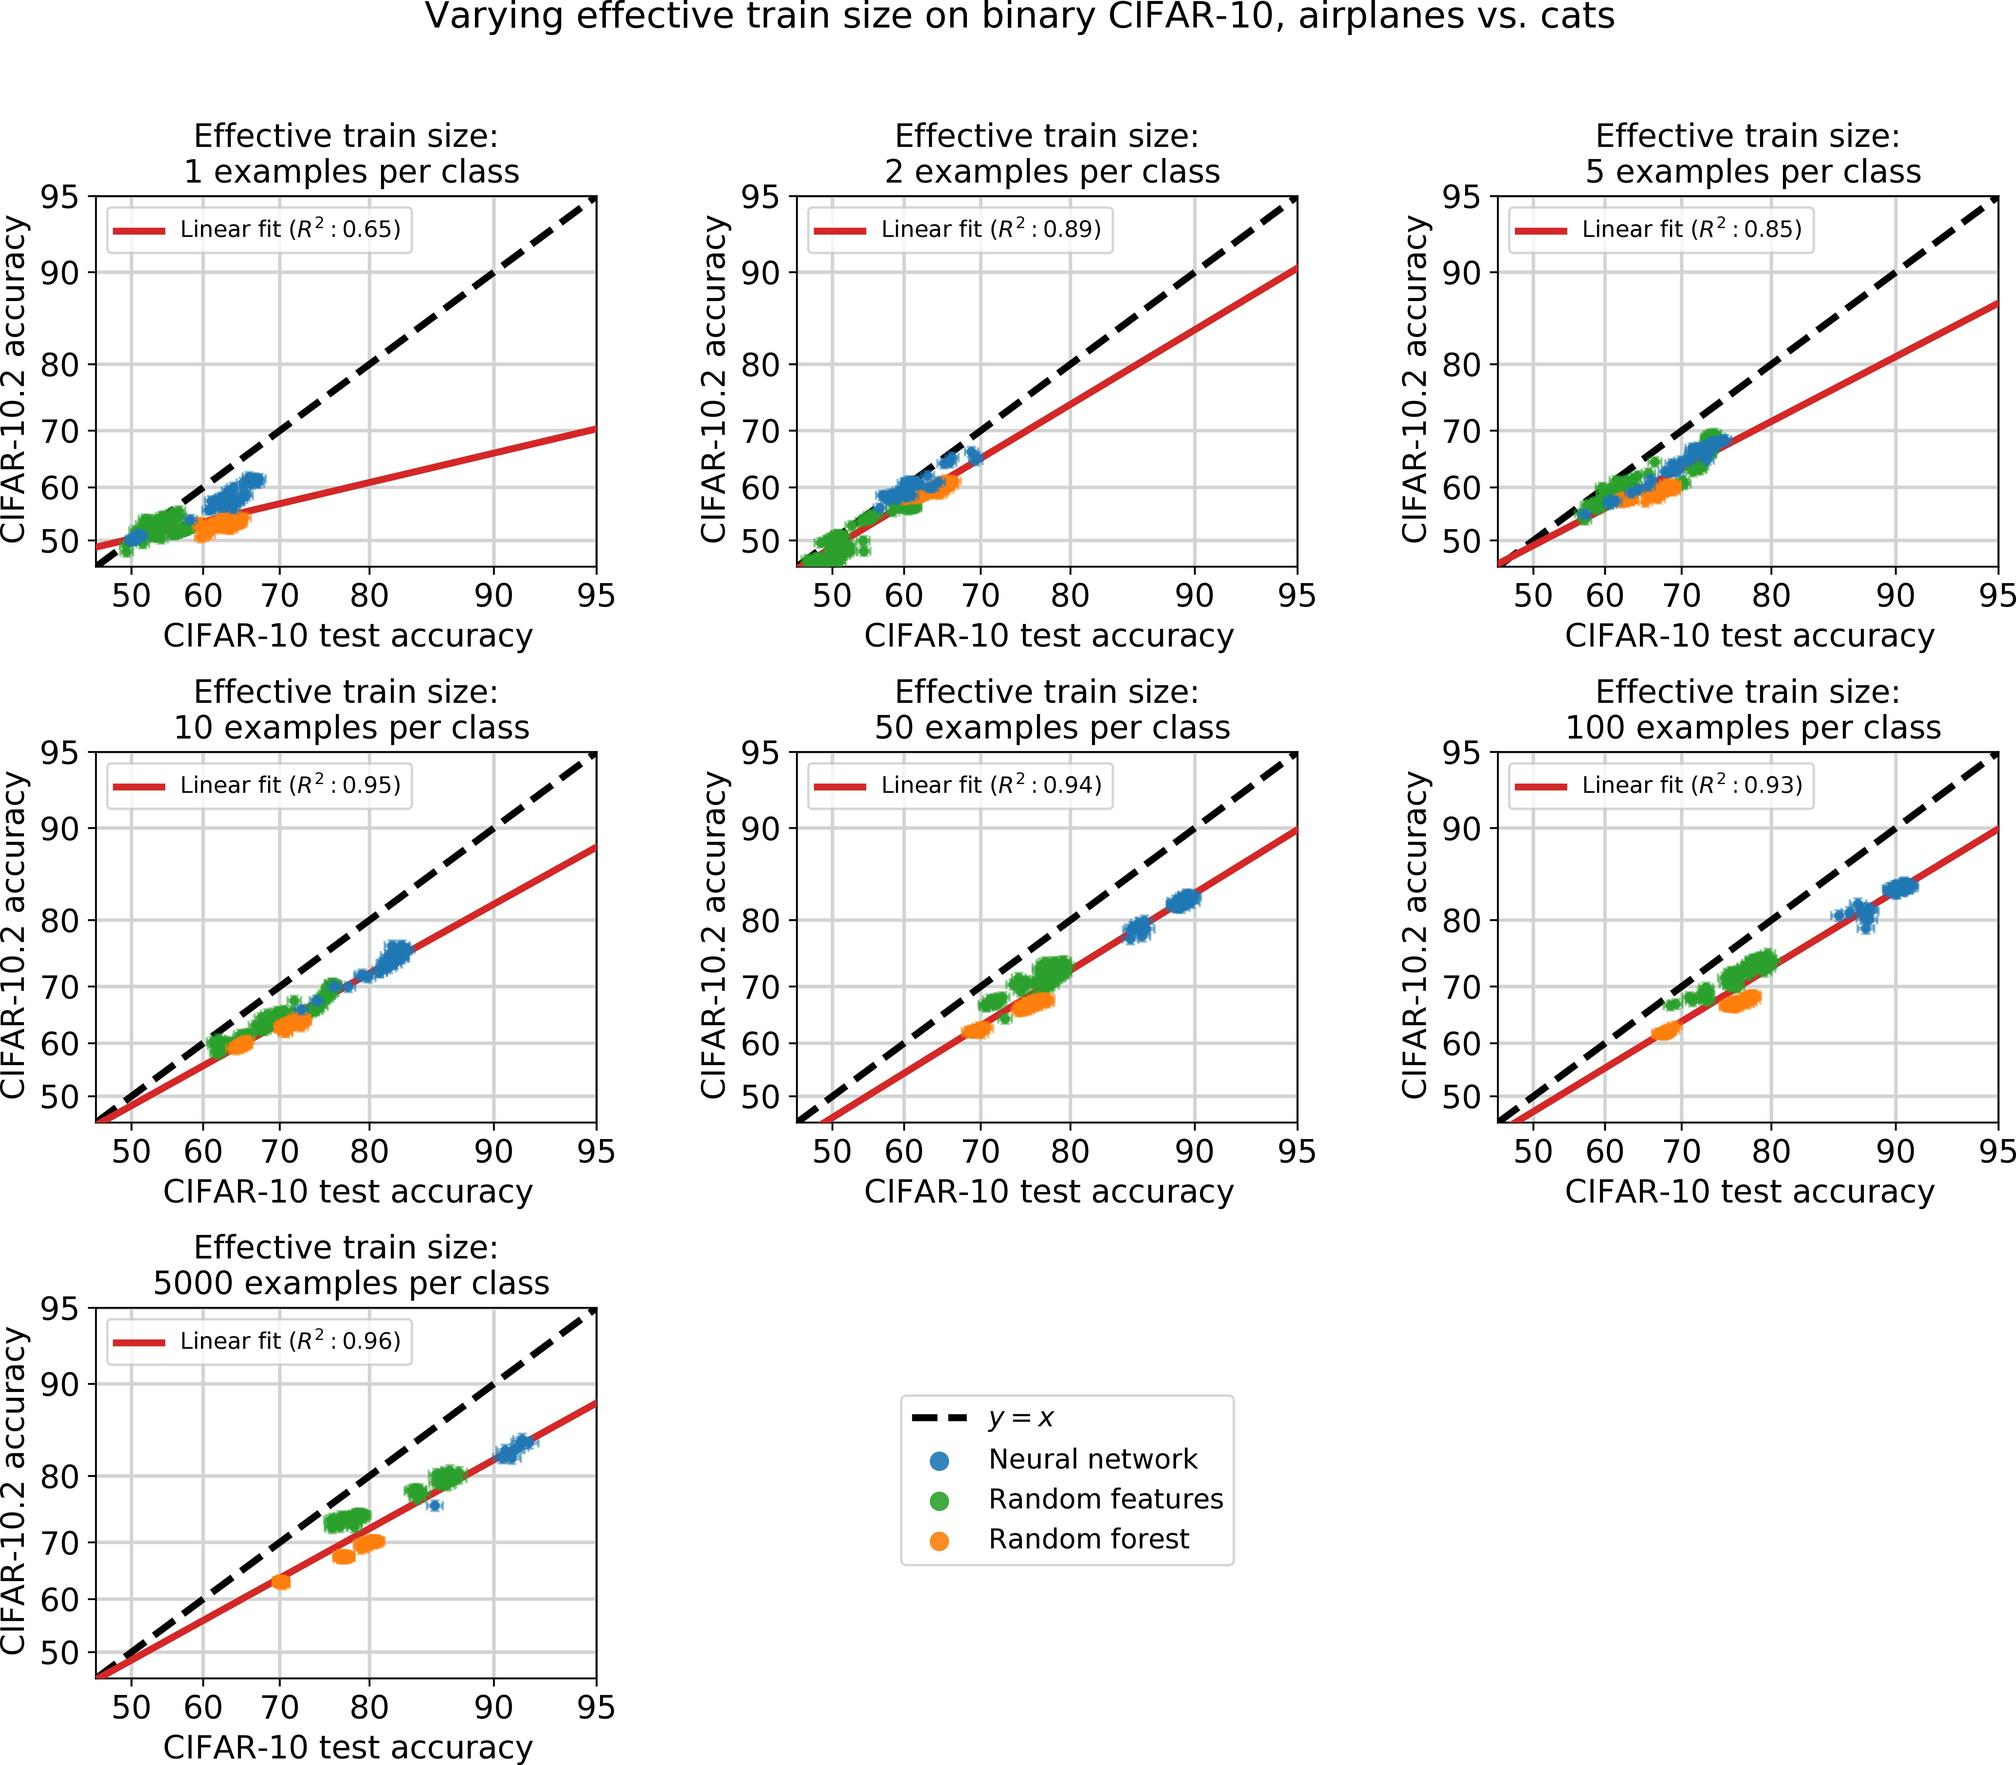Based on the graphs, what can be inferred about the relationship between CIFAR-10 test accuracy and the size of the training set? The series of graphs clearly demonstrate a positive correlation between the size of the training set and the CIFAR-10 test accuracy across various configurations. As the number of examples per class increases, from as few as 1 to as many as 5000, there is a consistent upward trend in test accuracy for both neural networks, random forests, and setups with random features. This trend is statistically supported by high R-squared values close to 1 in most cases, indicating a strong linear relationship between these two variables. 